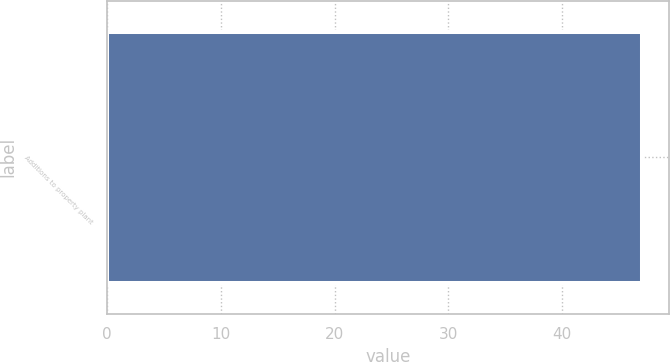Convert chart. <chart><loc_0><loc_0><loc_500><loc_500><bar_chart><fcel>Additions to property plant<nl><fcel>47<nl></chart> 